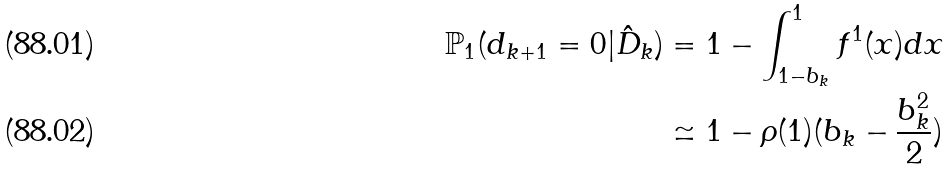Convert formula to latex. <formula><loc_0><loc_0><loc_500><loc_500>\mathbb { P } _ { 1 } ( d _ { k + 1 } = 0 | \hat { D } _ { k } ) & = 1 - \int _ { 1 - b _ { k } } ^ { 1 } f ^ { 1 } ( x ) d x \\ & \simeq 1 - \rho ( 1 ) ( b _ { k } - \frac { b _ { k } ^ { 2 } } { 2 } )</formula> 